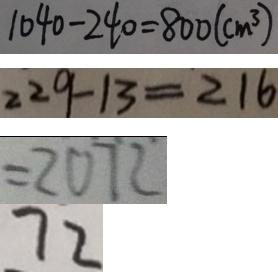<formula> <loc_0><loc_0><loc_500><loc_500>1 0 4 0 - 2 4 0 = 8 0 0 ( c m ^ { 3 } ) 
 2 2 9 - 1 3 = 2 1 6 
 = 2 0 7 2 
 7 2</formula> 